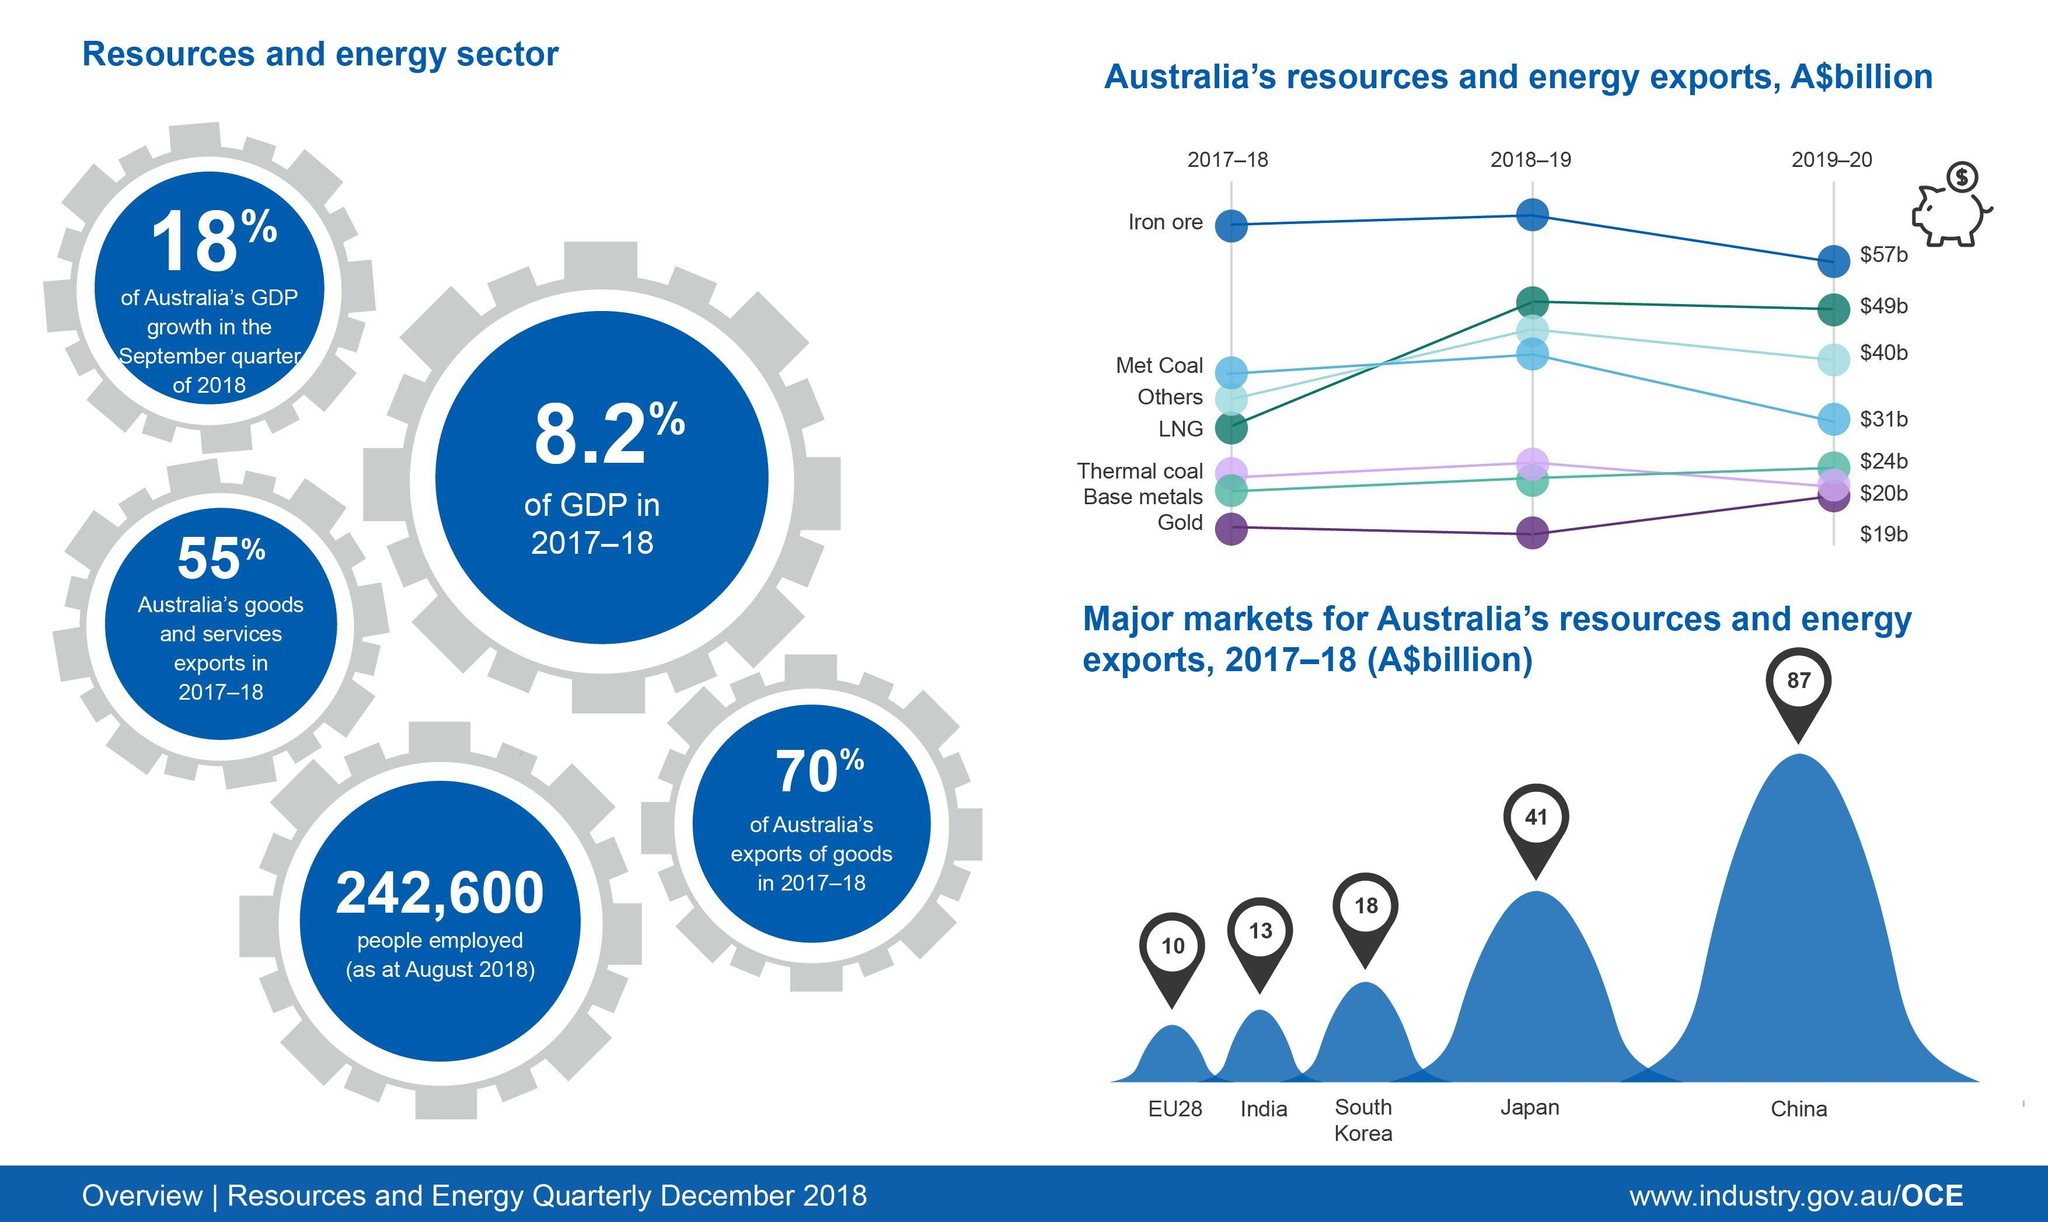What is Australia's export value of Met Coal in 2019-20?
Answer the question with a short phrase. $31b What is Australia's export value (in A$billion) of resources & energy to India in 2017-18? 13 What is the least exported product from Australia in 2017-18? Gold What percentage of the Australia's GDP is contributed by the Resources & energy sector in 2017-18? 8.2% What is Australia's export value of LNG in 2019-20? $49b What is Australia's export value (in A$billion) of resources & energy to Japan in 2017-18? 41 What is the most exported product from Australia in 2018-19? Iron ore Which country is the top importer of Australia's resources & energy in 2017-18? China 